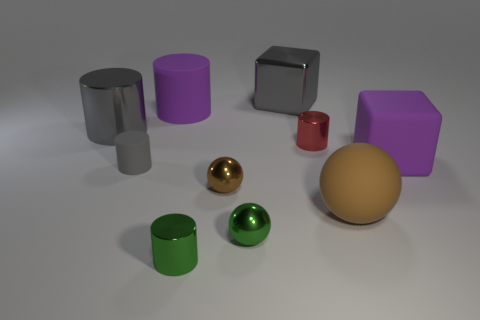Subtract all purple cylinders. How many cylinders are left? 4 Subtract all small gray cylinders. How many cylinders are left? 4 Subtract all brown cylinders. Subtract all blue spheres. How many cylinders are left? 5 Subtract all blocks. How many objects are left? 8 Add 1 gray things. How many gray things are left? 4 Add 1 red rubber things. How many red rubber things exist? 1 Subtract 0 cyan cylinders. How many objects are left? 10 Subtract all metal spheres. Subtract all large purple things. How many objects are left? 6 